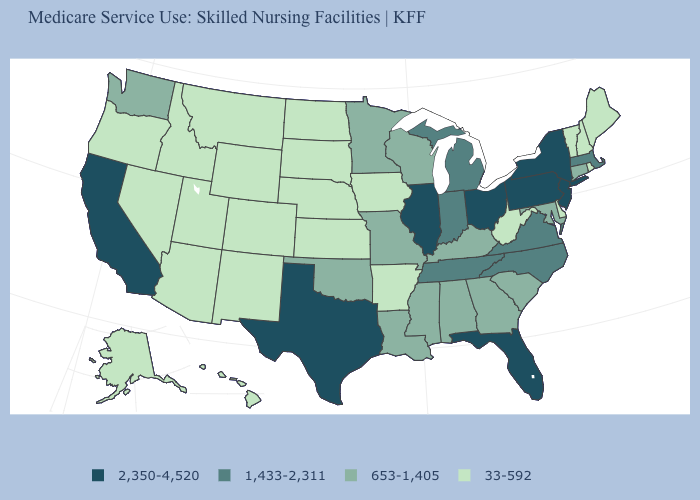Which states have the lowest value in the West?
Be succinct. Alaska, Arizona, Colorado, Hawaii, Idaho, Montana, Nevada, New Mexico, Oregon, Utah, Wyoming. What is the value of Nevada?
Quick response, please. 33-592. What is the value of West Virginia?
Answer briefly. 33-592. Name the states that have a value in the range 2,350-4,520?
Be succinct. California, Florida, Illinois, New Jersey, New York, Ohio, Pennsylvania, Texas. Does the first symbol in the legend represent the smallest category?
Give a very brief answer. No. Does Massachusetts have a higher value than Texas?
Answer briefly. No. Is the legend a continuous bar?
Concise answer only. No. What is the value of Kansas?
Write a very short answer. 33-592. Does Washington have the lowest value in the West?
Be succinct. No. Which states hav the highest value in the West?
Give a very brief answer. California. Is the legend a continuous bar?
Answer briefly. No. Name the states that have a value in the range 33-592?
Write a very short answer. Alaska, Arizona, Arkansas, Colorado, Delaware, Hawaii, Idaho, Iowa, Kansas, Maine, Montana, Nebraska, Nevada, New Hampshire, New Mexico, North Dakota, Oregon, Rhode Island, South Dakota, Utah, Vermont, West Virginia, Wyoming. What is the lowest value in the USA?
Give a very brief answer. 33-592. Name the states that have a value in the range 2,350-4,520?
Quick response, please. California, Florida, Illinois, New Jersey, New York, Ohio, Pennsylvania, Texas. 